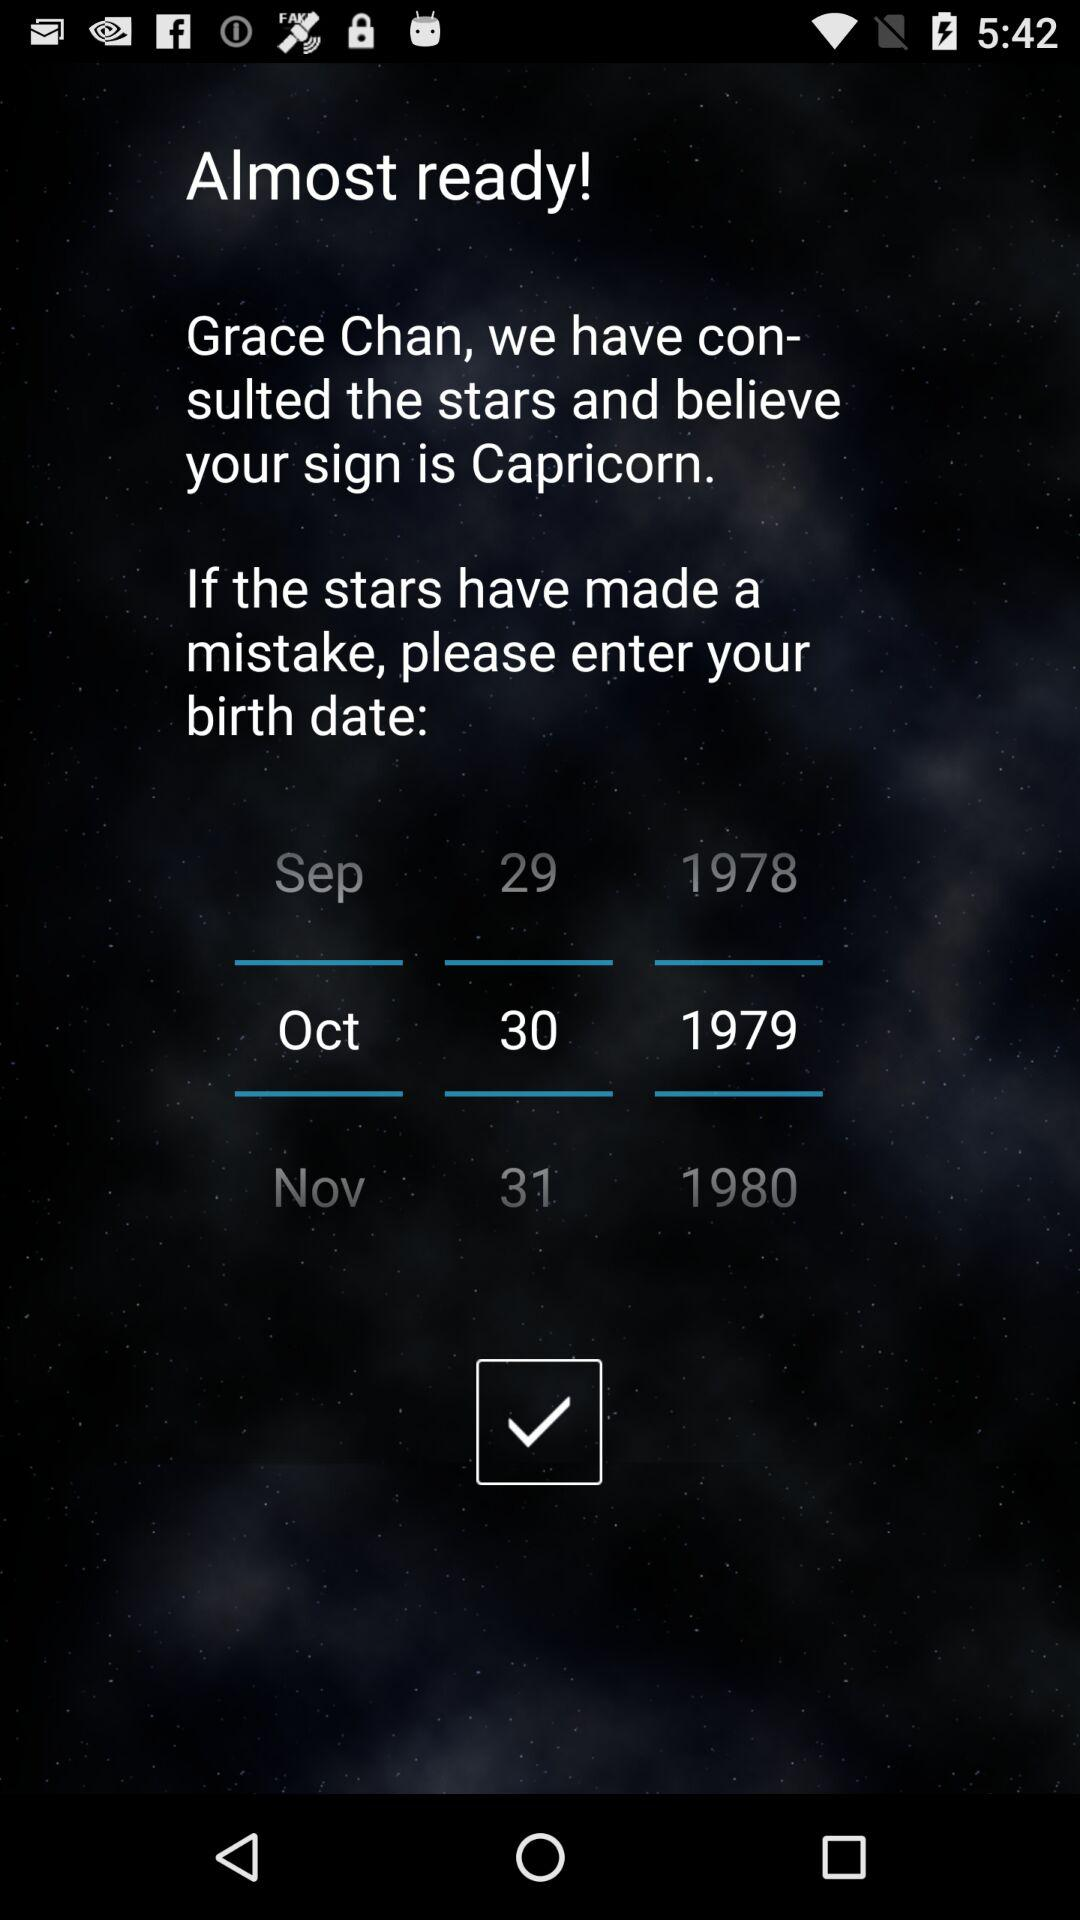What is the user name? The user name is Grace Chan. 